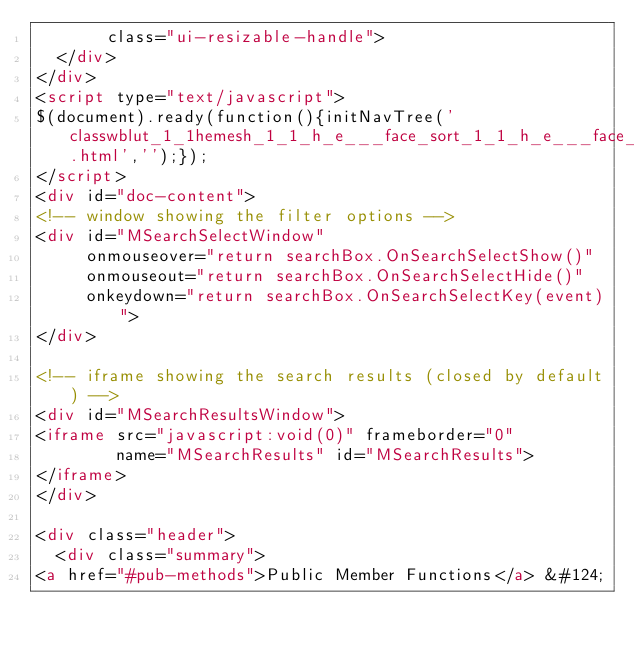Convert code to text. <code><loc_0><loc_0><loc_500><loc_500><_HTML_>       class="ui-resizable-handle">
  </div>
</div>
<script type="text/javascript">
$(document).ready(function(){initNavTree('classwblut_1_1hemesh_1_1_h_e___face_sort_1_1_h_e___face_sort_center_x_y_z.html','');});
</script>
<div id="doc-content">
<!-- window showing the filter options -->
<div id="MSearchSelectWindow"
     onmouseover="return searchBox.OnSearchSelectShow()"
     onmouseout="return searchBox.OnSearchSelectHide()"
     onkeydown="return searchBox.OnSearchSelectKey(event)">
</div>

<!-- iframe showing the search results (closed by default) -->
<div id="MSearchResultsWindow">
<iframe src="javascript:void(0)" frameborder="0" 
        name="MSearchResults" id="MSearchResults">
</iframe>
</div>

<div class="header">
  <div class="summary">
<a href="#pub-methods">Public Member Functions</a> &#124;</code> 